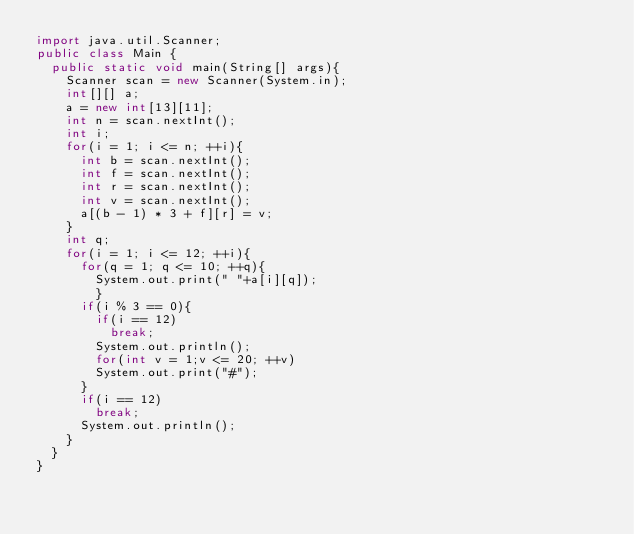Convert code to text. <code><loc_0><loc_0><loc_500><loc_500><_Java_>import java.util.Scanner;
public class Main {
	public static void main(String[] args){
		Scanner scan = new Scanner(System.in);
		int[][] a;
		a = new int[13][11];
		int n = scan.nextInt();
		int i;
		for(i = 1; i <= n; ++i){
			int b = scan.nextInt();
			int f = scan.nextInt();
			int r = scan.nextInt();
			int v = scan.nextInt();
			a[(b - 1) * 3 + f][r] = v;
		}
		int q;
		for(i = 1; i <= 12; ++i){
			for(q = 1; q <= 10; ++q){
				System.out.print(" "+a[i][q]);
				}
			if(i % 3 == 0){
				if(i == 12)
					break;
				System.out.println();
				for(int v = 1;v <= 20; ++v)
				System.out.print("#");
			}
			if(i == 12)
				break;
			System.out.println();
		}
	}
}</code> 